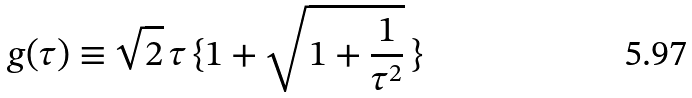Convert formula to latex. <formula><loc_0><loc_0><loc_500><loc_500>g ( \tau ) \equiv \sqrt { 2 } \, \tau \, \{ 1 + \sqrt { 1 + \frac { 1 } { \tau ^ { 2 } } } \, \}</formula> 